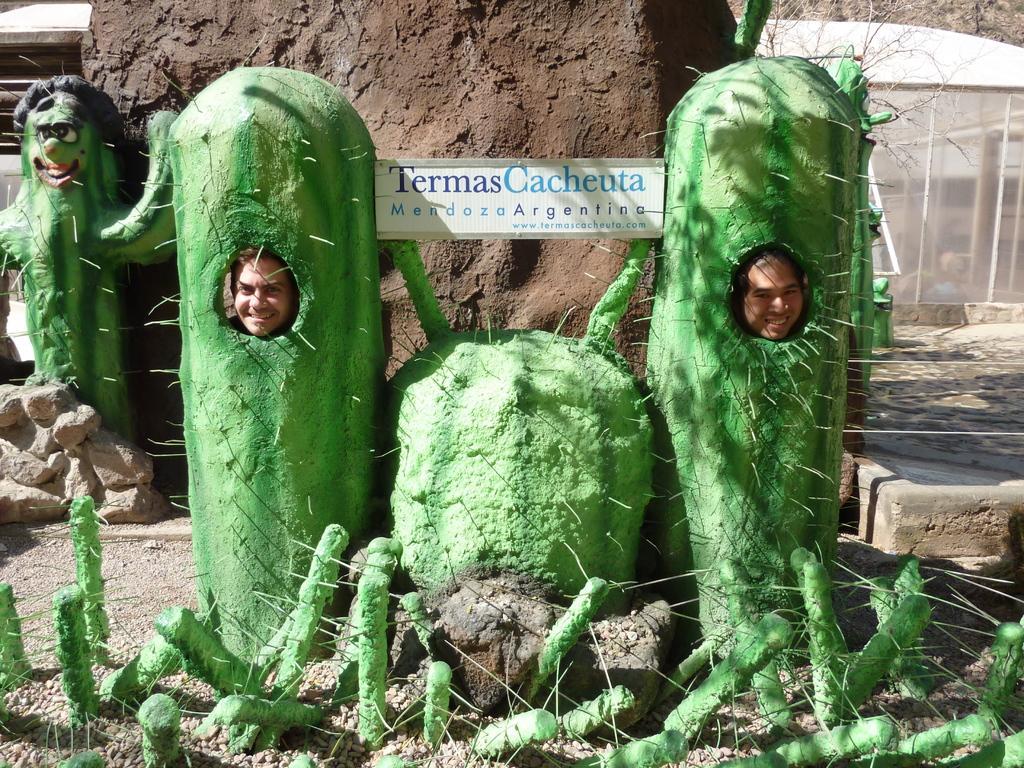How would you summarize this image in a sentence or two? There are statues of cactus plants. Inside the cactus plants there are two persons keeping the head on holes. Also there is a board with something written. In the back there is a wall. Also there are trees and a building. 